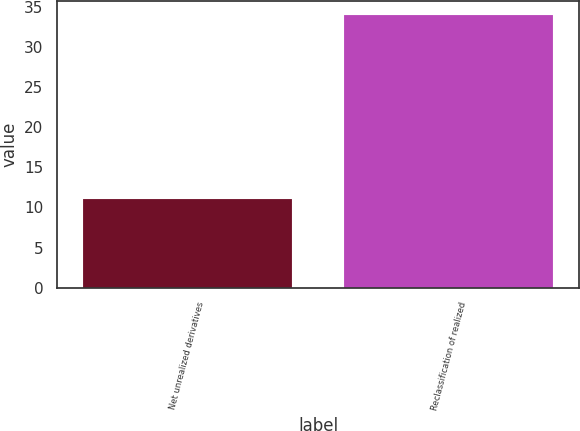Convert chart to OTSL. <chart><loc_0><loc_0><loc_500><loc_500><bar_chart><fcel>Net unrealized derivatives<fcel>Reclassification of realized<nl><fcel>11<fcel>34<nl></chart> 